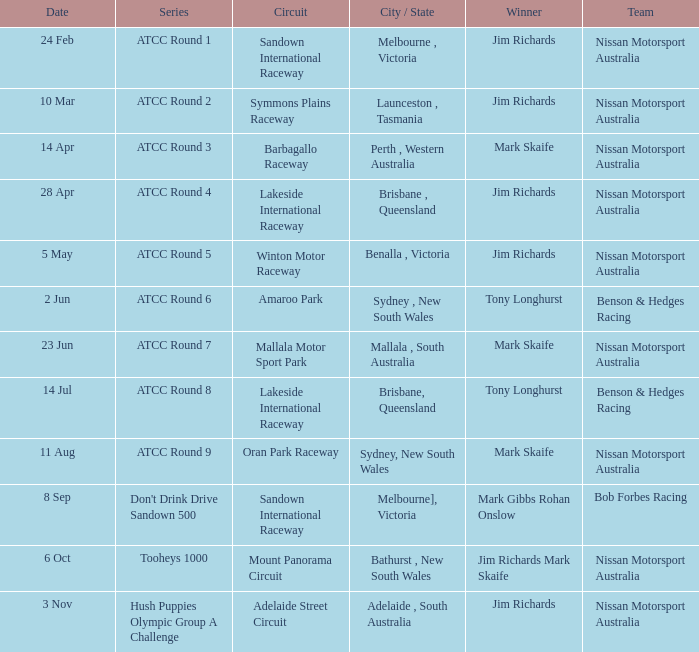What is the Team of Winner Mark Skaife in ATCC Round 7? Nissan Motorsport Australia. Would you mind parsing the complete table? {'header': ['Date', 'Series', 'Circuit', 'City / State', 'Winner', 'Team'], 'rows': [['24 Feb', 'ATCC Round 1', 'Sandown International Raceway', 'Melbourne , Victoria', 'Jim Richards', 'Nissan Motorsport Australia'], ['10 Mar', 'ATCC Round 2', 'Symmons Plains Raceway', 'Launceston , Tasmania', 'Jim Richards', 'Nissan Motorsport Australia'], ['14 Apr', 'ATCC Round 3', 'Barbagallo Raceway', 'Perth , Western Australia', 'Mark Skaife', 'Nissan Motorsport Australia'], ['28 Apr', 'ATCC Round 4', 'Lakeside International Raceway', 'Brisbane , Queensland', 'Jim Richards', 'Nissan Motorsport Australia'], ['5 May', 'ATCC Round 5', 'Winton Motor Raceway', 'Benalla , Victoria', 'Jim Richards', 'Nissan Motorsport Australia'], ['2 Jun', 'ATCC Round 6', 'Amaroo Park', 'Sydney , New South Wales', 'Tony Longhurst', 'Benson & Hedges Racing'], ['23 Jun', 'ATCC Round 7', 'Mallala Motor Sport Park', 'Mallala , South Australia', 'Mark Skaife', 'Nissan Motorsport Australia'], ['14 Jul', 'ATCC Round 8', 'Lakeside International Raceway', 'Brisbane, Queensland', 'Tony Longhurst', 'Benson & Hedges Racing'], ['11 Aug', 'ATCC Round 9', 'Oran Park Raceway', 'Sydney, New South Wales', 'Mark Skaife', 'Nissan Motorsport Australia'], ['8 Sep', "Don't Drink Drive Sandown 500", 'Sandown International Raceway', 'Melbourne], Victoria', 'Mark Gibbs Rohan Onslow', 'Bob Forbes Racing'], ['6 Oct', 'Tooheys 1000', 'Mount Panorama Circuit', 'Bathurst , New South Wales', 'Jim Richards Mark Skaife', 'Nissan Motorsport Australia'], ['3 Nov', 'Hush Puppies Olympic Group A Challenge', 'Adelaide Street Circuit', 'Adelaide , South Australia', 'Jim Richards', 'Nissan Motorsport Australia']]} 